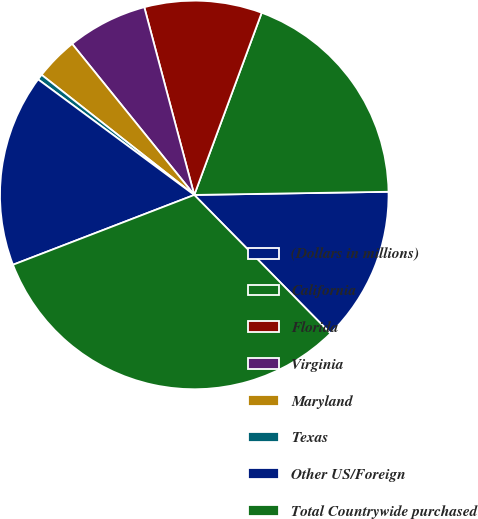Convert chart to OTSL. <chart><loc_0><loc_0><loc_500><loc_500><pie_chart><fcel>(Dollars in millions)<fcel>California<fcel>Florida<fcel>Virginia<fcel>Maryland<fcel>Texas<fcel>Other US/Foreign<fcel>Total Countrywide purchased<nl><fcel>12.89%<fcel>19.1%<fcel>9.78%<fcel>6.68%<fcel>3.57%<fcel>0.47%<fcel>15.99%<fcel>31.52%<nl></chart> 